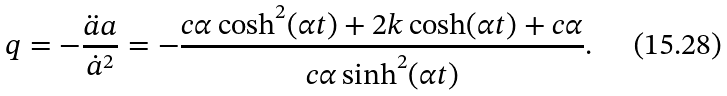Convert formula to latex. <formula><loc_0><loc_0><loc_500><loc_500>q = - \frac { \ddot { a } a } { \dot { a } ^ { 2 } } = - \frac { c \alpha \cosh ^ { 2 } ( \alpha t ) + 2 k \cosh ( \alpha t ) + c \alpha } { c \alpha \sinh ^ { 2 } ( \alpha t ) } .</formula> 